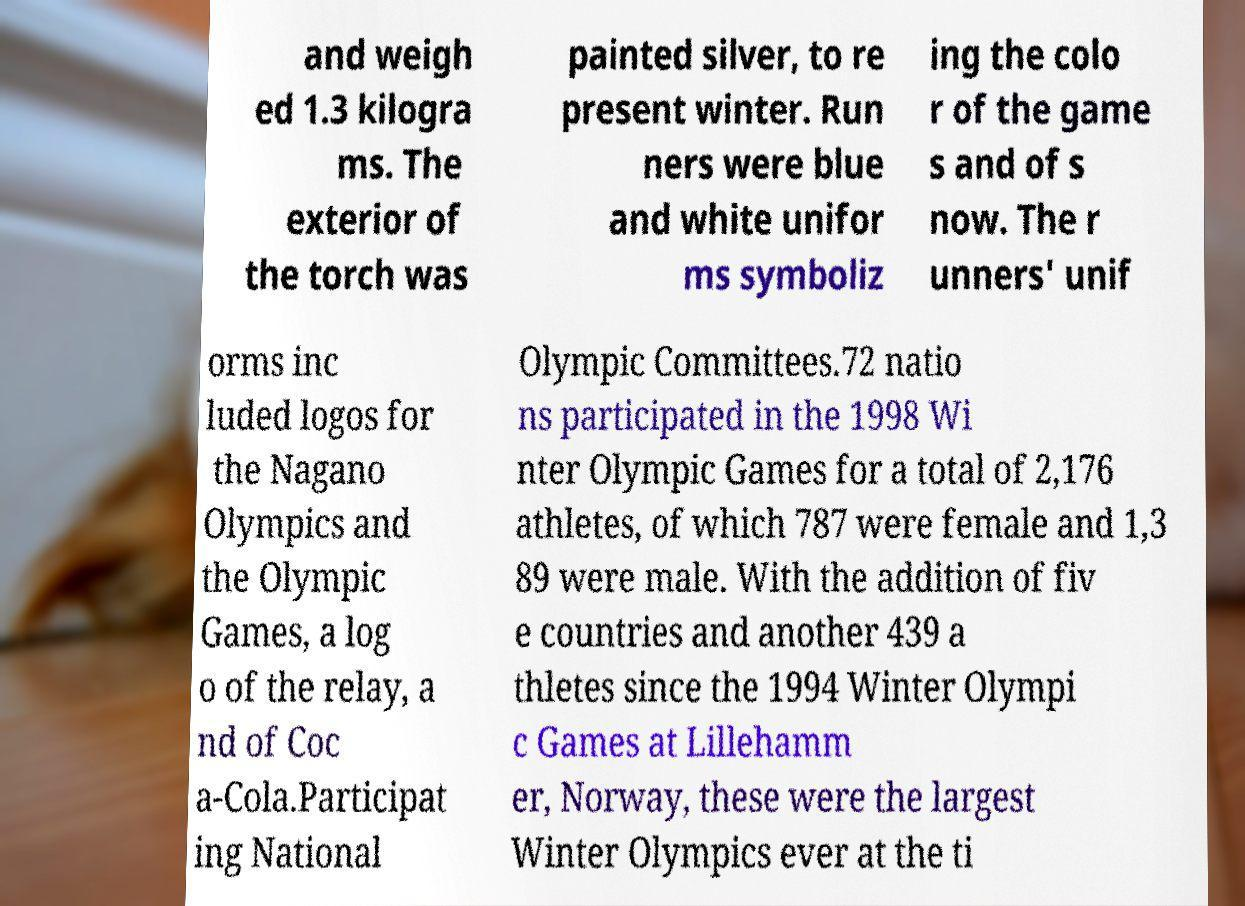Please read and relay the text visible in this image. What does it say? and weigh ed 1.3 kilogra ms. The exterior of the torch was painted silver, to re present winter. Run ners were blue and white unifor ms symboliz ing the colo r of the game s and of s now. The r unners' unif orms inc luded logos for the Nagano Olympics and the Olympic Games, a log o of the relay, a nd of Coc a-Cola.Participat ing National Olympic Committees.72 natio ns participated in the 1998 Wi nter Olympic Games for a total of 2,176 athletes, of which 787 were female and 1,3 89 were male. With the addition of fiv e countries and another 439 a thletes since the 1994 Winter Olympi c Games at Lillehamm er, Norway, these were the largest Winter Olympics ever at the ti 